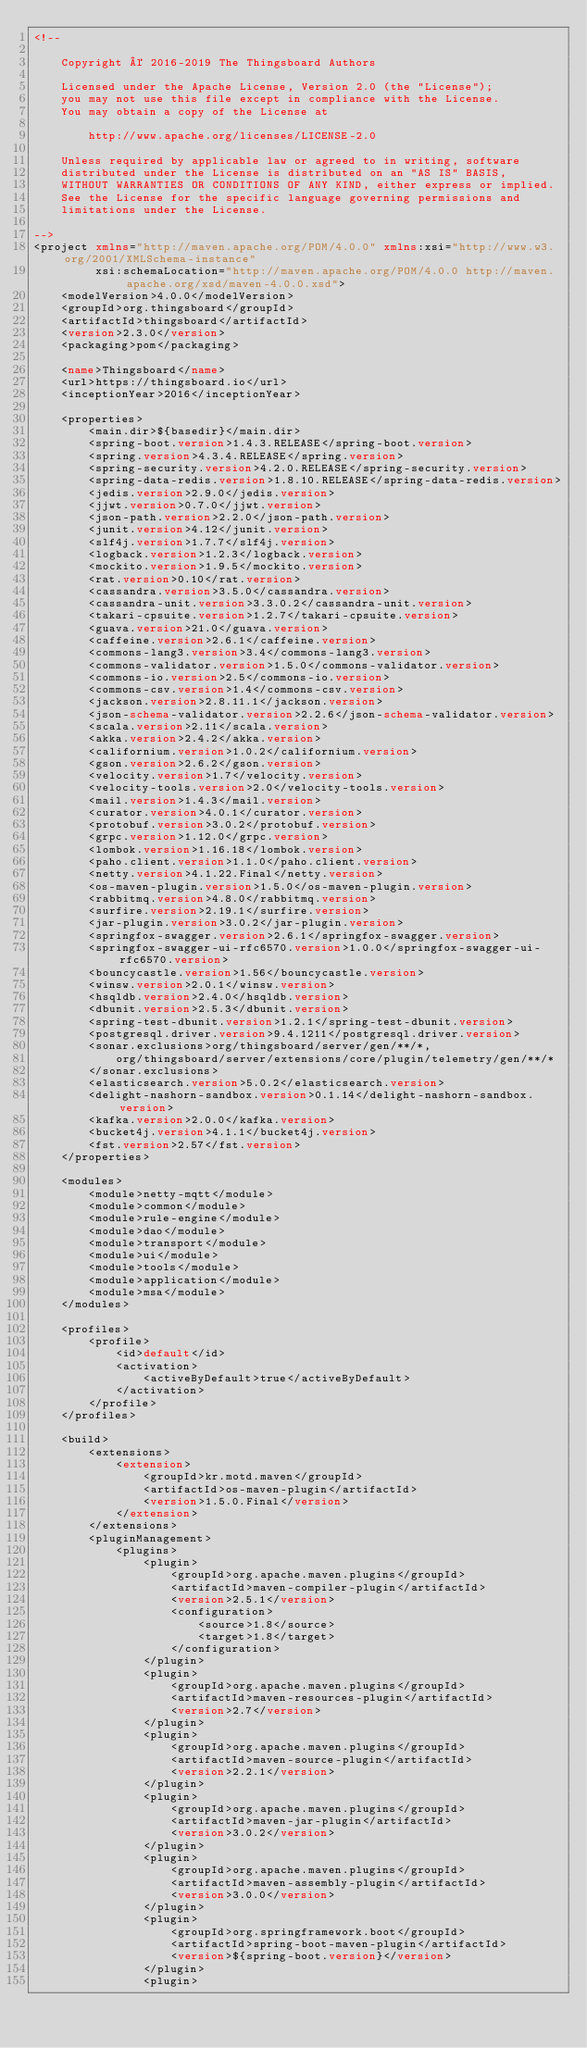Convert code to text. <code><loc_0><loc_0><loc_500><loc_500><_XML_><!--

    Copyright © 2016-2019 The Thingsboard Authors

    Licensed under the Apache License, Version 2.0 (the "License");
    you may not use this file except in compliance with the License.
    You may obtain a copy of the License at

        http://www.apache.org/licenses/LICENSE-2.0

    Unless required by applicable law or agreed to in writing, software
    distributed under the License is distributed on an "AS IS" BASIS,
    WITHOUT WARRANTIES OR CONDITIONS OF ANY KIND, either express or implied.
    See the License for the specific language governing permissions and
    limitations under the License.

-->
<project xmlns="http://maven.apache.org/POM/4.0.0" xmlns:xsi="http://www.w3.org/2001/XMLSchema-instance"
         xsi:schemaLocation="http://maven.apache.org/POM/4.0.0 http://maven.apache.org/xsd/maven-4.0.0.xsd">
    <modelVersion>4.0.0</modelVersion>
    <groupId>org.thingsboard</groupId>
    <artifactId>thingsboard</artifactId>
    <version>2.3.0</version>
    <packaging>pom</packaging>

    <name>Thingsboard</name>
    <url>https://thingsboard.io</url>
    <inceptionYear>2016</inceptionYear>

    <properties>
        <main.dir>${basedir}</main.dir>
        <spring-boot.version>1.4.3.RELEASE</spring-boot.version>
        <spring.version>4.3.4.RELEASE</spring.version>
        <spring-security.version>4.2.0.RELEASE</spring-security.version>
        <spring-data-redis.version>1.8.10.RELEASE</spring-data-redis.version>
        <jedis.version>2.9.0</jedis.version>
        <jjwt.version>0.7.0</jjwt.version>
        <json-path.version>2.2.0</json-path.version>
        <junit.version>4.12</junit.version>
        <slf4j.version>1.7.7</slf4j.version>
        <logback.version>1.2.3</logback.version>
        <mockito.version>1.9.5</mockito.version>
        <rat.version>0.10</rat.version>
        <cassandra.version>3.5.0</cassandra.version>
        <cassandra-unit.version>3.3.0.2</cassandra-unit.version>
        <takari-cpsuite.version>1.2.7</takari-cpsuite.version>
        <guava.version>21.0</guava.version>
        <caffeine.version>2.6.1</caffeine.version>
        <commons-lang3.version>3.4</commons-lang3.version>
        <commons-validator.version>1.5.0</commons-validator.version>
        <commons-io.version>2.5</commons-io.version>
        <commons-csv.version>1.4</commons-csv.version>
        <jackson.version>2.8.11.1</jackson.version>
        <json-schema-validator.version>2.2.6</json-schema-validator.version>
        <scala.version>2.11</scala.version>
        <akka.version>2.4.2</akka.version>
        <californium.version>1.0.2</californium.version>
        <gson.version>2.6.2</gson.version>
        <velocity.version>1.7</velocity.version>
        <velocity-tools.version>2.0</velocity-tools.version>
        <mail.version>1.4.3</mail.version>
        <curator.version>4.0.1</curator.version>
        <protobuf.version>3.0.2</protobuf.version>
        <grpc.version>1.12.0</grpc.version>
        <lombok.version>1.16.18</lombok.version>
        <paho.client.version>1.1.0</paho.client.version>
        <netty.version>4.1.22.Final</netty.version>
        <os-maven-plugin.version>1.5.0</os-maven-plugin.version>
        <rabbitmq.version>4.8.0</rabbitmq.version>
        <surfire.version>2.19.1</surfire.version>
        <jar-plugin.version>3.0.2</jar-plugin.version>
        <springfox-swagger.version>2.6.1</springfox-swagger.version>
        <springfox-swagger-ui-rfc6570.version>1.0.0</springfox-swagger-ui-rfc6570.version>
        <bouncycastle.version>1.56</bouncycastle.version>
        <winsw.version>2.0.1</winsw.version>
        <hsqldb.version>2.4.0</hsqldb.version>
        <dbunit.version>2.5.3</dbunit.version>
        <spring-test-dbunit.version>1.2.1</spring-test-dbunit.version>
        <postgresql.driver.version>9.4.1211</postgresql.driver.version>
        <sonar.exclusions>org/thingsboard/server/gen/**/*,
            org/thingsboard/server/extensions/core/plugin/telemetry/gen/**/*
        </sonar.exclusions>
        <elasticsearch.version>5.0.2</elasticsearch.version>
        <delight-nashorn-sandbox.version>0.1.14</delight-nashorn-sandbox.version>
        <kafka.version>2.0.0</kafka.version>
        <bucket4j.version>4.1.1</bucket4j.version>
        <fst.version>2.57</fst.version>
    </properties>

    <modules>
        <module>netty-mqtt</module>
        <module>common</module>
        <module>rule-engine</module>
        <module>dao</module>
        <module>transport</module>
        <module>ui</module>
        <module>tools</module>
        <module>application</module>
        <module>msa</module>
    </modules>

    <profiles>
        <profile>
            <id>default</id>
            <activation>
                <activeByDefault>true</activeByDefault>
            </activation>
        </profile>
    </profiles>

    <build>
        <extensions>
            <extension>
                <groupId>kr.motd.maven</groupId>
                <artifactId>os-maven-plugin</artifactId>
                <version>1.5.0.Final</version>
            </extension>
        </extensions>
        <pluginManagement>
            <plugins>
                <plugin>
                    <groupId>org.apache.maven.plugins</groupId>
                    <artifactId>maven-compiler-plugin</artifactId>
                    <version>2.5.1</version>
                    <configuration>
                        <source>1.8</source>
                        <target>1.8</target>
                    </configuration>
                </plugin>
                <plugin>
                    <groupId>org.apache.maven.plugins</groupId>
                    <artifactId>maven-resources-plugin</artifactId>
                    <version>2.7</version>
                </plugin>
                <plugin>
                    <groupId>org.apache.maven.plugins</groupId>
                    <artifactId>maven-source-plugin</artifactId>
                    <version>2.2.1</version>
                </plugin>
                <plugin>
                    <groupId>org.apache.maven.plugins</groupId>
                    <artifactId>maven-jar-plugin</artifactId>
                    <version>3.0.2</version>
                </plugin>
                <plugin>
                    <groupId>org.apache.maven.plugins</groupId>
                    <artifactId>maven-assembly-plugin</artifactId>
                    <version>3.0.0</version>
                </plugin>
                <plugin>
                    <groupId>org.springframework.boot</groupId>
                    <artifactId>spring-boot-maven-plugin</artifactId>
                    <version>${spring-boot.version}</version>
                </plugin>
                <plugin></code> 